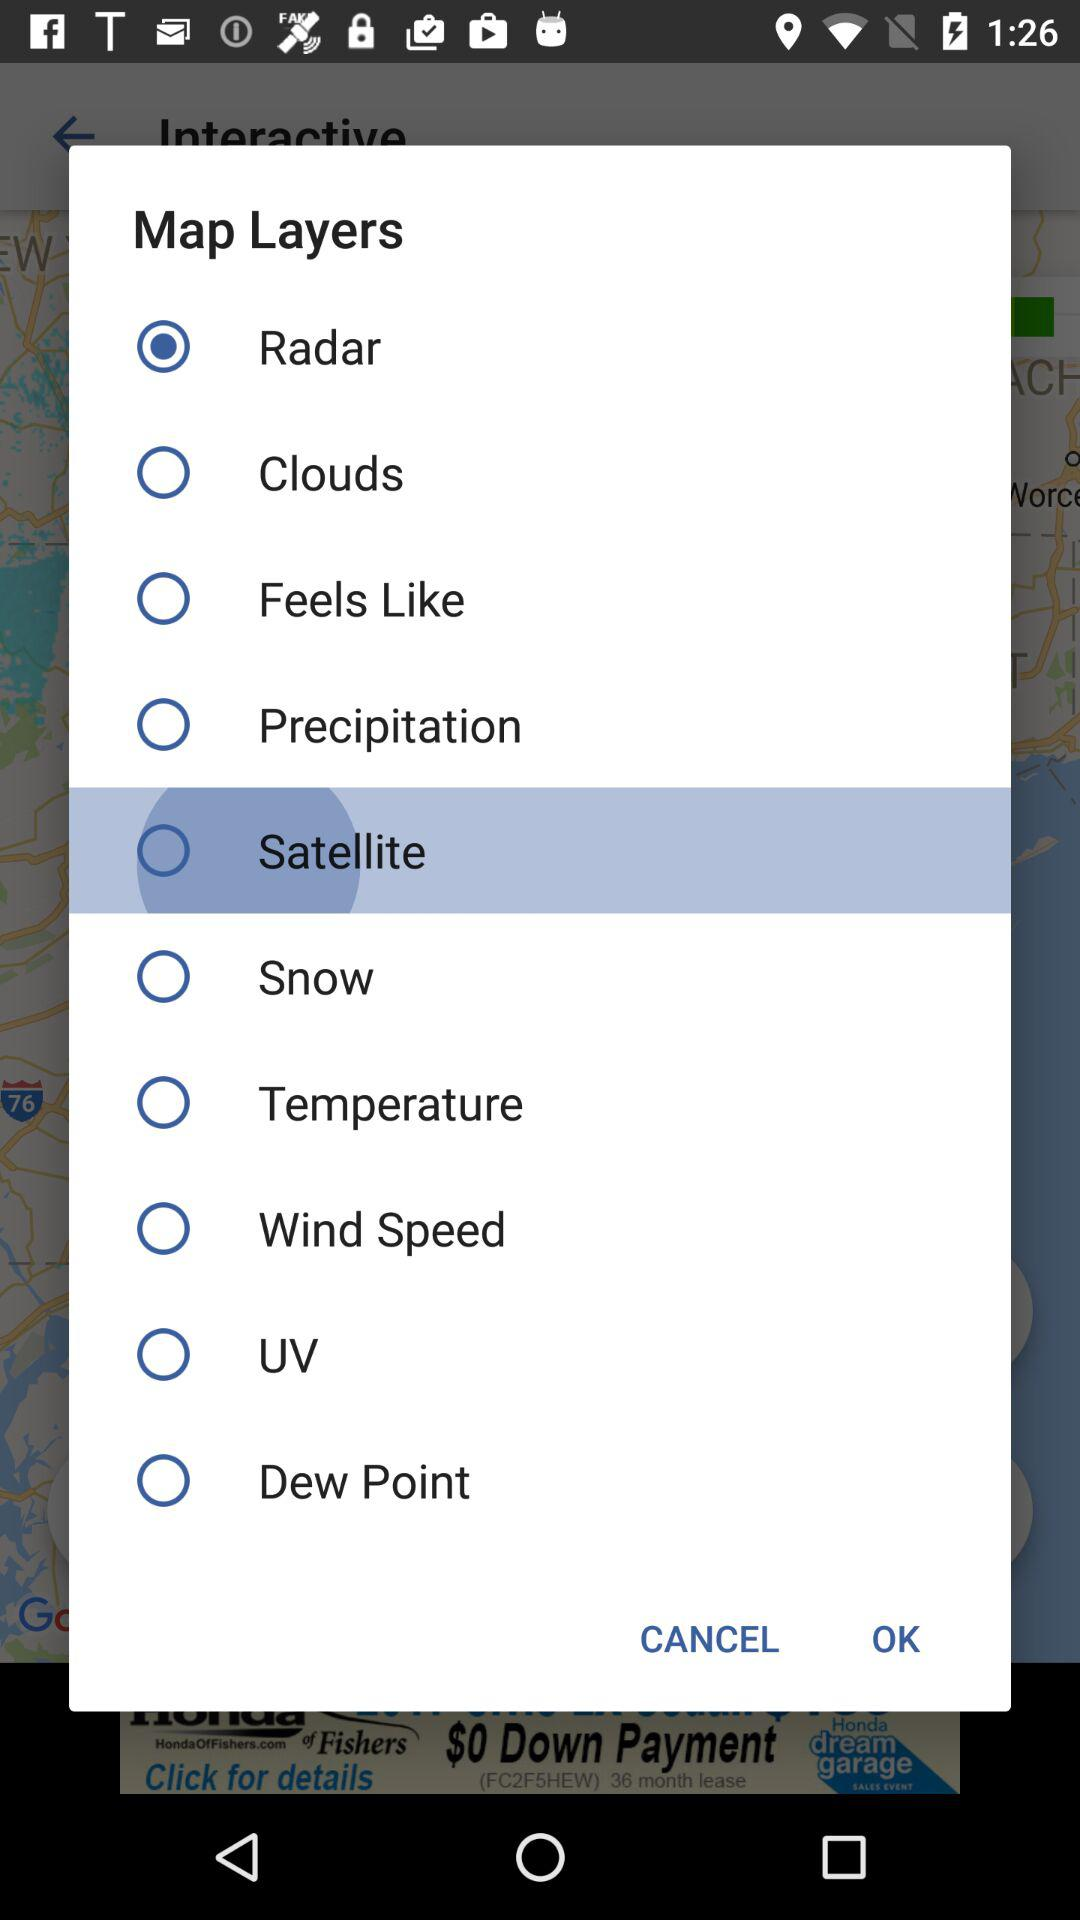Which map layer is selected? The selected map layer is "Radar". 